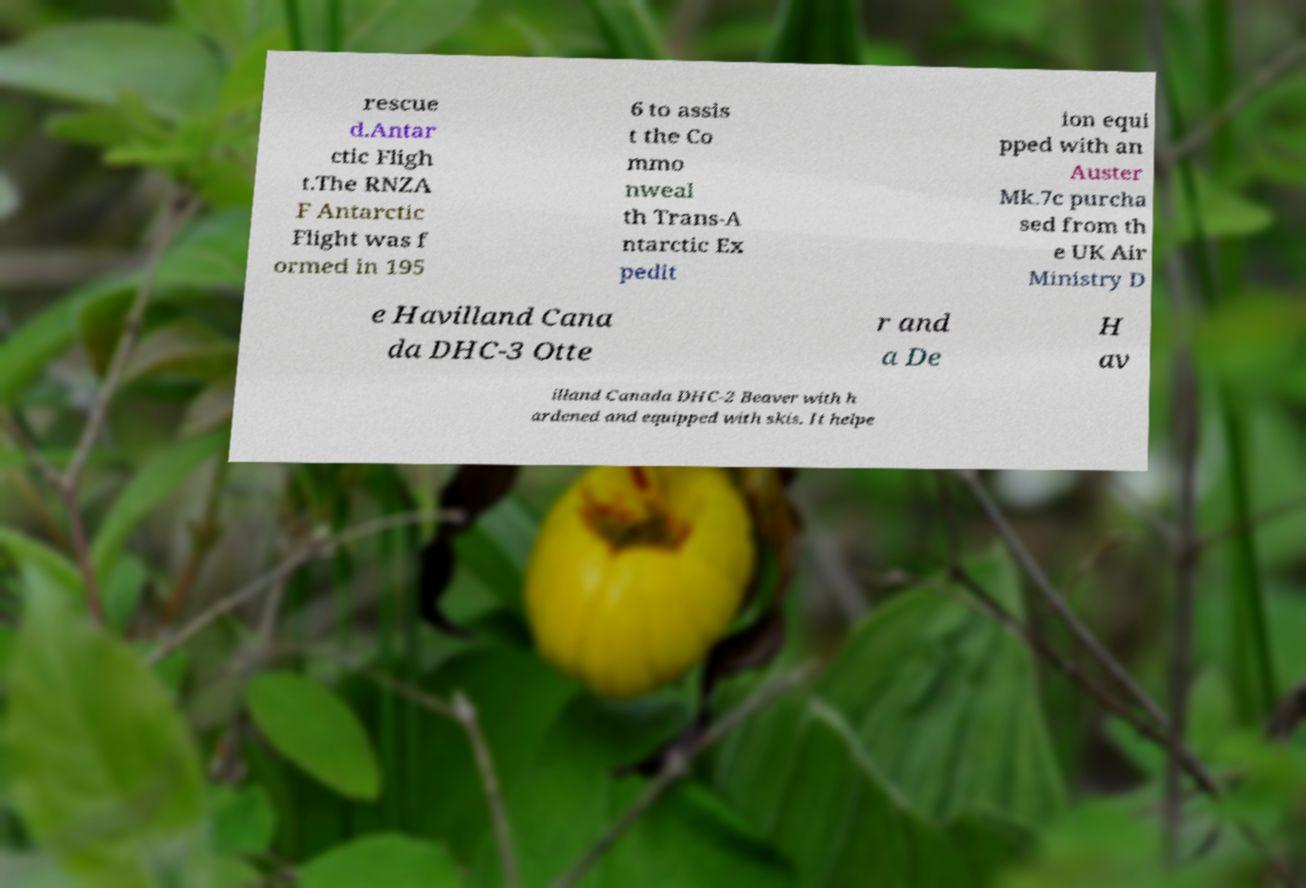Can you accurately transcribe the text from the provided image for me? rescue d.Antar ctic Fligh t.The RNZA F Antarctic Flight was f ormed in 195 6 to assis t the Co mmo nweal th Trans-A ntarctic Ex pedit ion equi pped with an Auster Mk.7c purcha sed from th e UK Air Ministry D e Havilland Cana da DHC-3 Otte r and a De H av illand Canada DHC-2 Beaver with h ardened and equipped with skis. It helpe 